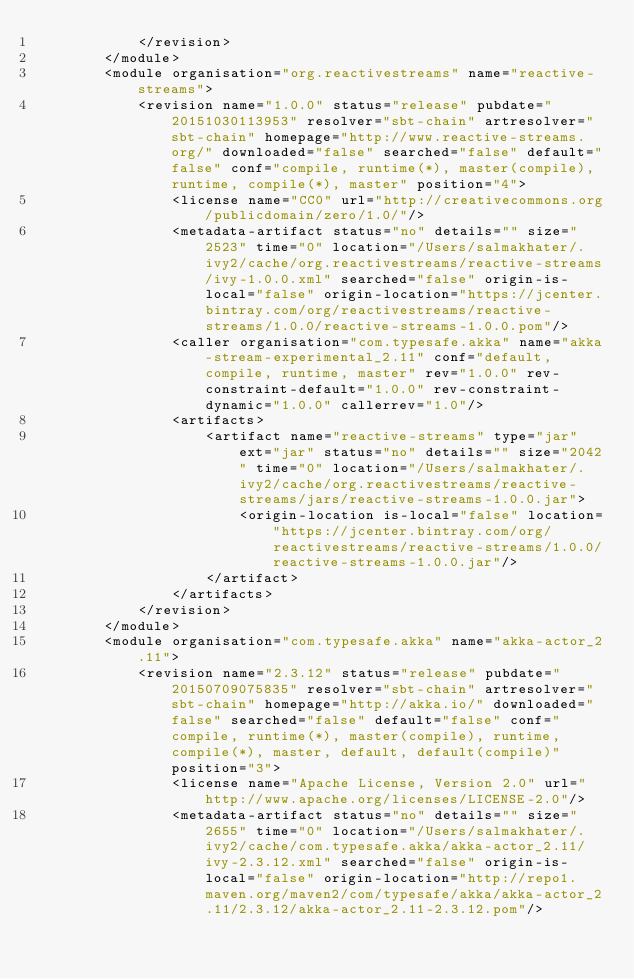Convert code to text. <code><loc_0><loc_0><loc_500><loc_500><_XML_>			</revision>
		</module>
		<module organisation="org.reactivestreams" name="reactive-streams">
			<revision name="1.0.0" status="release" pubdate="20151030113953" resolver="sbt-chain" artresolver="sbt-chain" homepage="http://www.reactive-streams.org/" downloaded="false" searched="false" default="false" conf="compile, runtime(*), master(compile), runtime, compile(*), master" position="4">
				<license name="CC0" url="http://creativecommons.org/publicdomain/zero/1.0/"/>
				<metadata-artifact status="no" details="" size="2523" time="0" location="/Users/salmakhater/.ivy2/cache/org.reactivestreams/reactive-streams/ivy-1.0.0.xml" searched="false" origin-is-local="false" origin-location="https://jcenter.bintray.com/org/reactivestreams/reactive-streams/1.0.0/reactive-streams-1.0.0.pom"/>
				<caller organisation="com.typesafe.akka" name="akka-stream-experimental_2.11" conf="default, compile, runtime, master" rev="1.0.0" rev-constraint-default="1.0.0" rev-constraint-dynamic="1.0.0" callerrev="1.0"/>
				<artifacts>
					<artifact name="reactive-streams" type="jar" ext="jar" status="no" details="" size="2042" time="0" location="/Users/salmakhater/.ivy2/cache/org.reactivestreams/reactive-streams/jars/reactive-streams-1.0.0.jar">
						<origin-location is-local="false" location="https://jcenter.bintray.com/org/reactivestreams/reactive-streams/1.0.0/reactive-streams-1.0.0.jar"/>
					</artifact>
				</artifacts>
			</revision>
		</module>
		<module organisation="com.typesafe.akka" name="akka-actor_2.11">
			<revision name="2.3.12" status="release" pubdate="20150709075835" resolver="sbt-chain" artresolver="sbt-chain" homepage="http://akka.io/" downloaded="false" searched="false" default="false" conf="compile, runtime(*), master(compile), runtime, compile(*), master, default, default(compile)" position="3">
				<license name="Apache License, Version 2.0" url="http://www.apache.org/licenses/LICENSE-2.0"/>
				<metadata-artifact status="no" details="" size="2655" time="0" location="/Users/salmakhater/.ivy2/cache/com.typesafe.akka/akka-actor_2.11/ivy-2.3.12.xml" searched="false" origin-is-local="false" origin-location="http://repo1.maven.org/maven2/com/typesafe/akka/akka-actor_2.11/2.3.12/akka-actor_2.11-2.3.12.pom"/></code> 